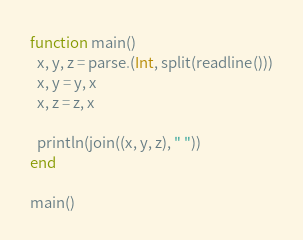<code> <loc_0><loc_0><loc_500><loc_500><_Julia_>
function main()
  x, y, z = parse.(Int, split(readline()))
  x, y = y, x
  x, z = z, x

  println(join((x, y, z), " "))
end

main()
</code> 